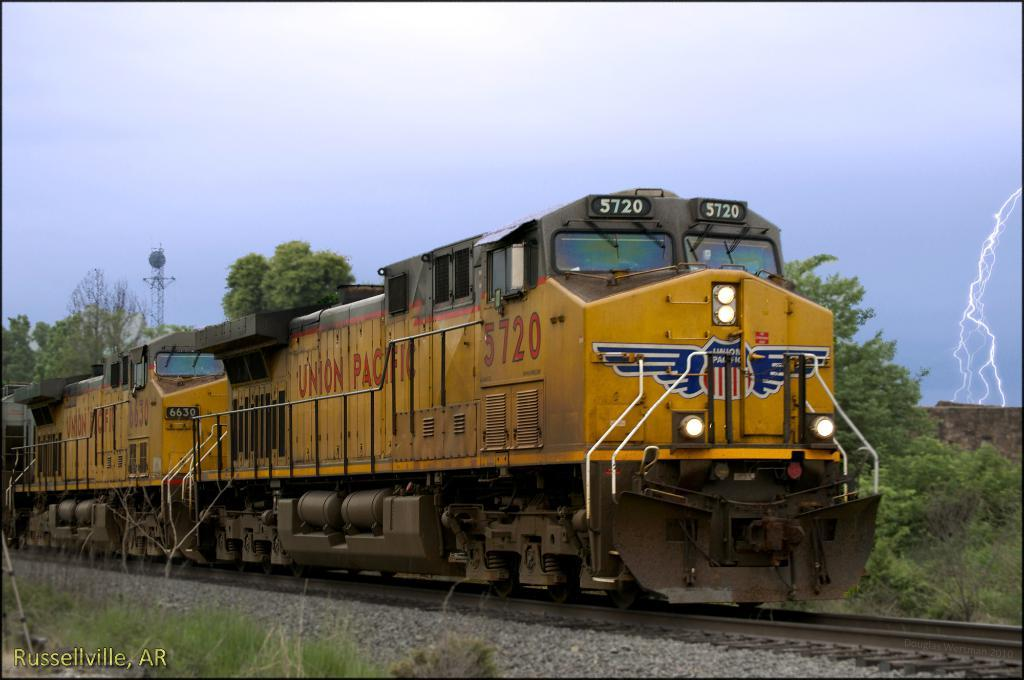What mode of transportation can be seen in the image? There is a train on the track in the image. What type of vegetation is visible in the image? Plants, grass, and trees are present in the image. What type of structure can be seen in the image? There is a wall and a tower in the image. What is the weather like in the image? The image depicts a thunderstorm. What part of the natural environment is visible in the image? The sky is visible in the image. How many lizards are sitting on the chair in the image? There are no lizards or chairs present in the image. What color is the egg that is being cracked open in the image? There is no egg present in the image. 